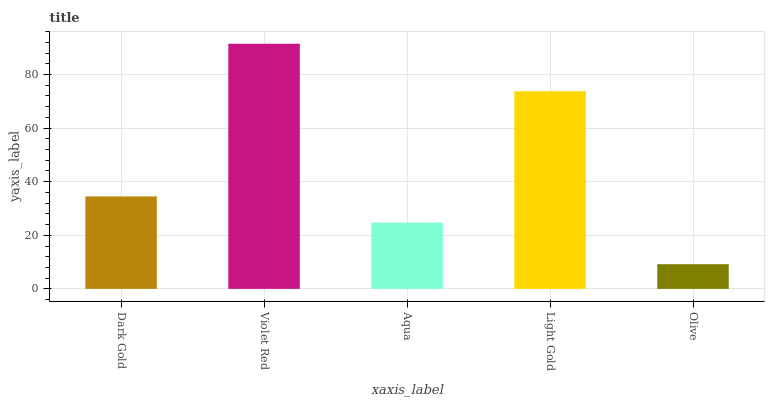Is Olive the minimum?
Answer yes or no. Yes. Is Violet Red the maximum?
Answer yes or no. Yes. Is Aqua the minimum?
Answer yes or no. No. Is Aqua the maximum?
Answer yes or no. No. Is Violet Red greater than Aqua?
Answer yes or no. Yes. Is Aqua less than Violet Red?
Answer yes or no. Yes. Is Aqua greater than Violet Red?
Answer yes or no. No. Is Violet Red less than Aqua?
Answer yes or no. No. Is Dark Gold the high median?
Answer yes or no. Yes. Is Dark Gold the low median?
Answer yes or no. Yes. Is Light Gold the high median?
Answer yes or no. No. Is Light Gold the low median?
Answer yes or no. No. 